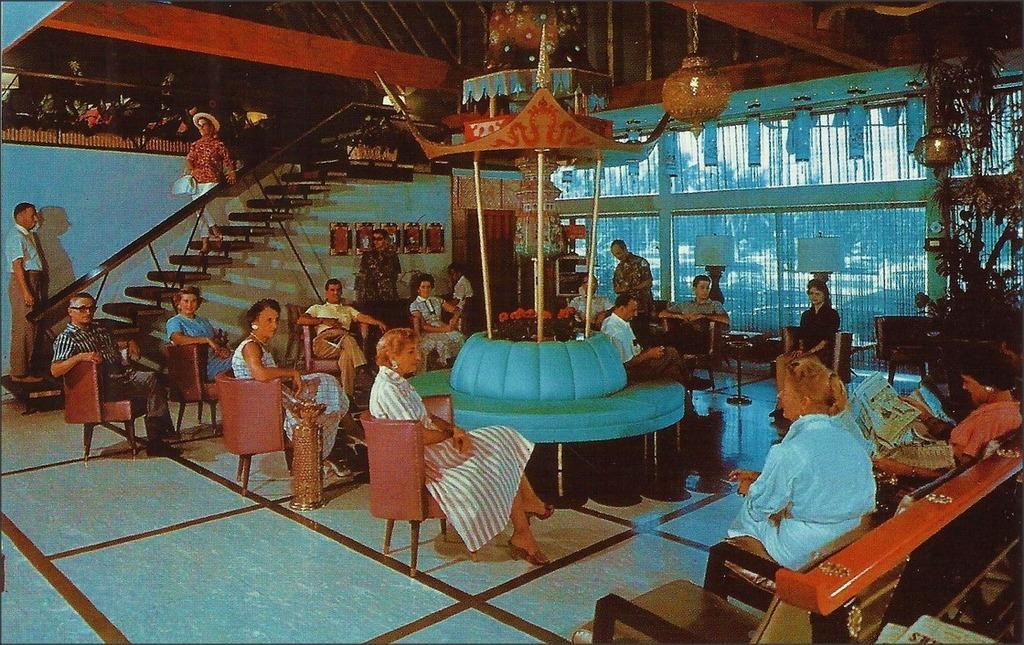Please provide a concise description of this image. In this image people are sitting on the chair and looking somewhere. 